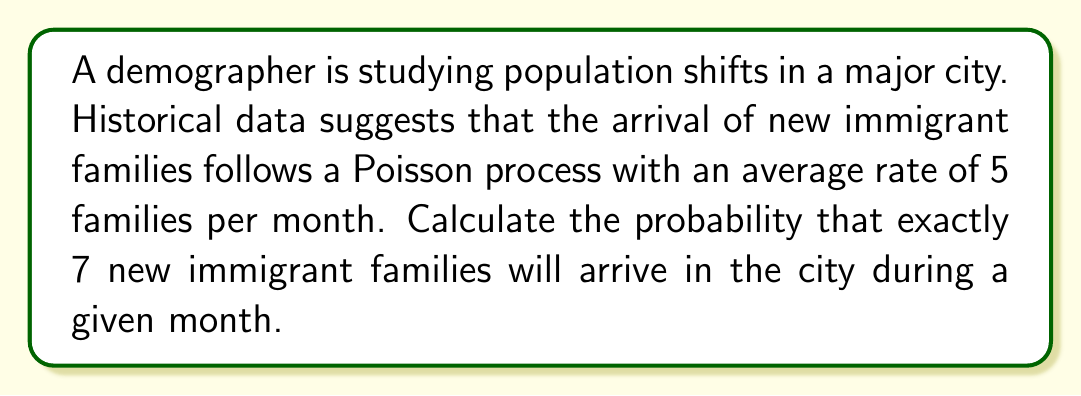Provide a solution to this math problem. To solve this problem, we'll use the Poisson distribution formula. The Poisson distribution is given by:

$$P(X = k) = \frac{e^{-\lambda} \lambda^k}{k!}$$

Where:
- $\lambda$ is the average rate of events in the given time period
- $k$ is the number of events we're interested in
- $e$ is Euler's number (approximately 2.71828)

Given:
- $\lambda = 5$ (average of 5 families per month)
- $k = 7$ (we want exactly 7 families)

Step 1: Plug the values into the Poisson formula:

$$P(X = 7) = \frac{e^{-5} 5^7}{7!}$$

Step 2: Calculate $5^7$:
$$5^7 = 78,125$$

Step 3: Calculate $7!$:
$$7! = 7 \times 6 \times 5 \times 4 \times 3 \times 2 \times 1 = 5,040$$

Step 4: Calculate $e^{-5}$:
$$e^{-5} \approx 0.006738$$

Step 5: Put it all together:

$$P(X = 7) = \frac{0.006738 \times 78,125}{5,040} \approx 0.1044$$

Step 6: Convert to a percentage:
$$0.1044 \times 100\% = 10.44\%$$

Therefore, the probability of exactly 7 new immigrant families arriving in the city during a given month is approximately 10.44%.
Answer: 10.44% 